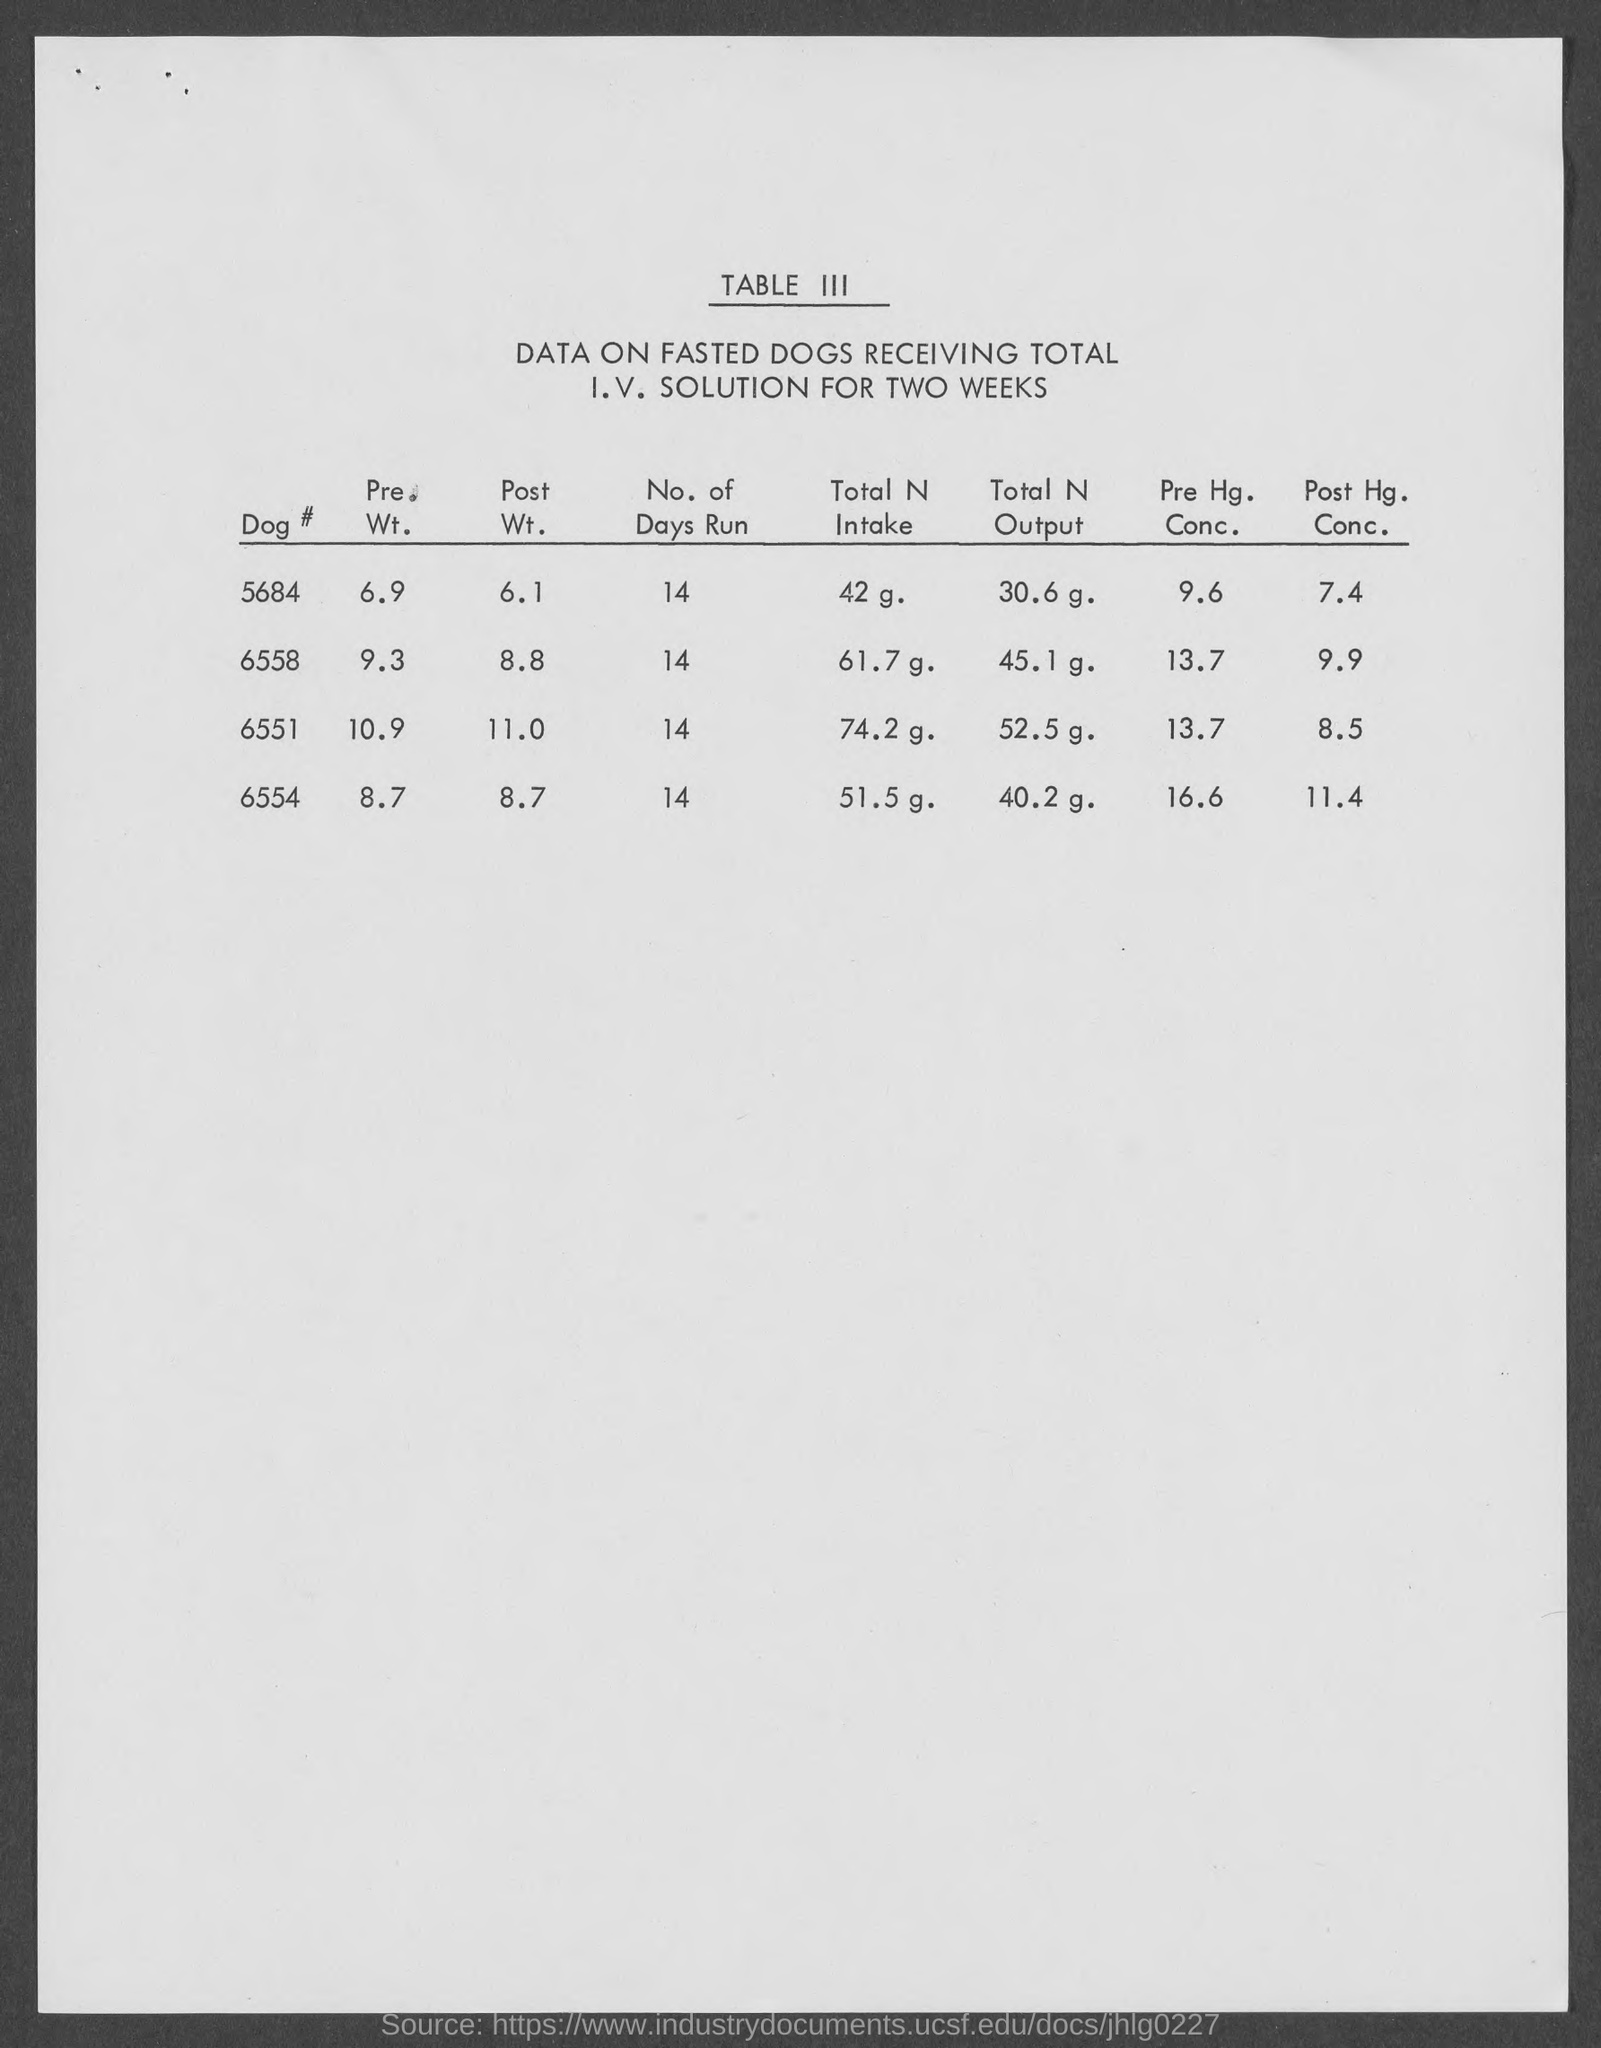Mention a couple of crucial points in this snapshot. The weight of Dog #6558 is 9.3 pounds. What is the weight of dog number 6554? 8.7... The post-Hg concentration of Dog #6558 is 9.9... The weight of dog number 6551 is 10.9 grams. The table number mentioned is Table III. 